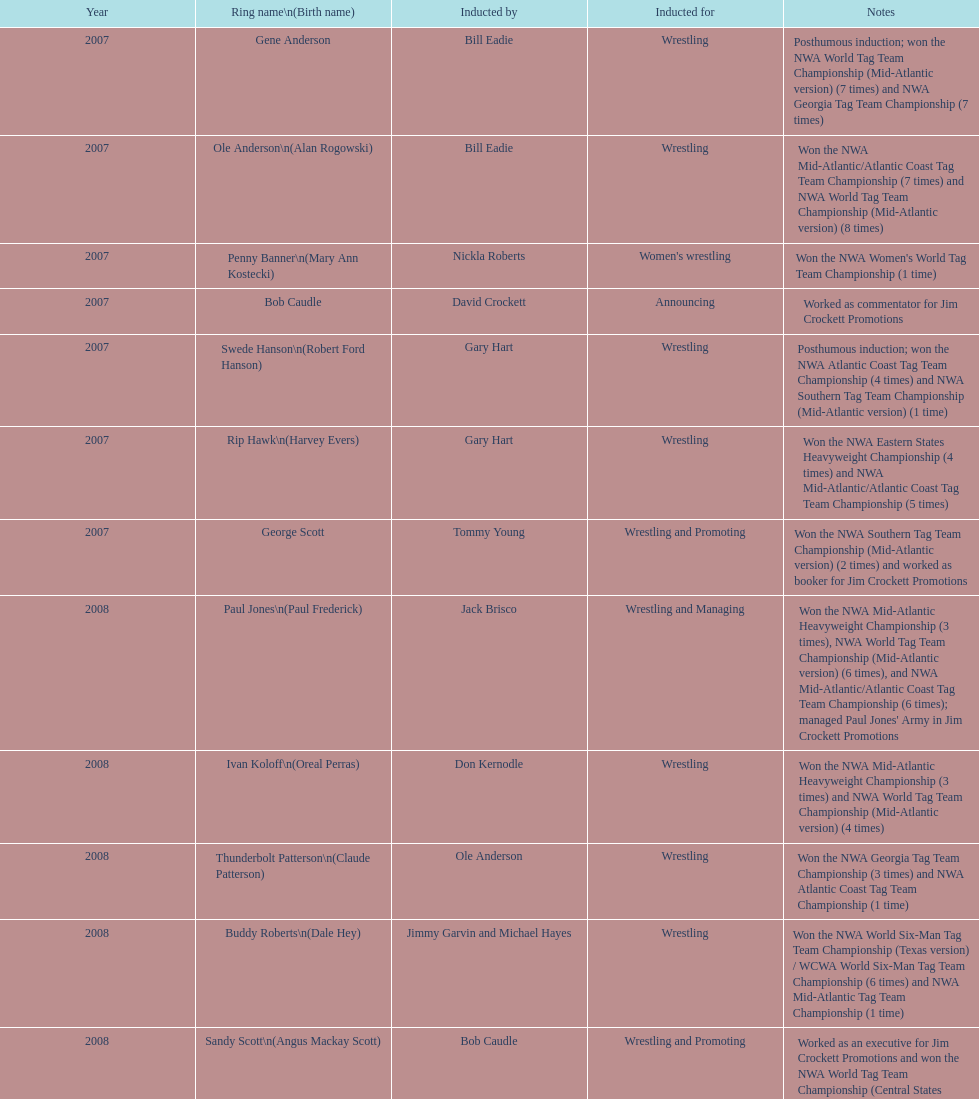Who was the only person to be inducted for wrestling and managing? Paul Jones. Can you give me this table as a dict? {'header': ['Year', 'Ring name\\n(Birth name)', 'Inducted by', 'Inducted for', 'Notes'], 'rows': [['2007', 'Gene Anderson', 'Bill Eadie', 'Wrestling', 'Posthumous induction; won the NWA World Tag Team Championship (Mid-Atlantic version) (7 times) and NWA Georgia Tag Team Championship (7 times)'], ['2007', 'Ole Anderson\\n(Alan Rogowski)', 'Bill Eadie', 'Wrestling', 'Won the NWA Mid-Atlantic/Atlantic Coast Tag Team Championship (7 times) and NWA World Tag Team Championship (Mid-Atlantic version) (8 times)'], ['2007', 'Penny Banner\\n(Mary Ann Kostecki)', 'Nickla Roberts', "Women's wrestling", "Won the NWA Women's World Tag Team Championship (1 time)"], ['2007', 'Bob Caudle', 'David Crockett', 'Announcing', 'Worked as commentator for Jim Crockett Promotions'], ['2007', 'Swede Hanson\\n(Robert Ford Hanson)', 'Gary Hart', 'Wrestling', 'Posthumous induction; won the NWA Atlantic Coast Tag Team Championship (4 times) and NWA Southern Tag Team Championship (Mid-Atlantic version) (1 time)'], ['2007', 'Rip Hawk\\n(Harvey Evers)', 'Gary Hart', 'Wrestling', 'Won the NWA Eastern States Heavyweight Championship (4 times) and NWA Mid-Atlantic/Atlantic Coast Tag Team Championship (5 times)'], ['2007', 'George Scott', 'Tommy Young', 'Wrestling and Promoting', 'Won the NWA Southern Tag Team Championship (Mid-Atlantic version) (2 times) and worked as booker for Jim Crockett Promotions'], ['2008', 'Paul Jones\\n(Paul Frederick)', 'Jack Brisco', 'Wrestling and Managing', "Won the NWA Mid-Atlantic Heavyweight Championship (3 times), NWA World Tag Team Championship (Mid-Atlantic version) (6 times), and NWA Mid-Atlantic/Atlantic Coast Tag Team Championship (6 times); managed Paul Jones' Army in Jim Crockett Promotions"], ['2008', 'Ivan Koloff\\n(Oreal Perras)', 'Don Kernodle', 'Wrestling', 'Won the NWA Mid-Atlantic Heavyweight Championship (3 times) and NWA World Tag Team Championship (Mid-Atlantic version) (4 times)'], ['2008', 'Thunderbolt Patterson\\n(Claude Patterson)', 'Ole Anderson', 'Wrestling', 'Won the NWA Georgia Tag Team Championship (3 times) and NWA Atlantic Coast Tag Team Championship (1 time)'], ['2008', 'Buddy Roberts\\n(Dale Hey)', 'Jimmy Garvin and Michael Hayes', 'Wrestling', 'Won the NWA World Six-Man Tag Team Championship (Texas version) / WCWA World Six-Man Tag Team Championship (6 times) and NWA Mid-Atlantic Tag Team Championship (1 time)'], ['2008', 'Sandy Scott\\n(Angus Mackay Scott)', 'Bob Caudle', 'Wrestling and Promoting', 'Worked as an executive for Jim Crockett Promotions and won the NWA World Tag Team Championship (Central States version) (1 time) and NWA Southern Tag Team Championship (Mid-Atlantic version) (3 times)'], ['2008', 'Grizzly Smith\\n(Aurelian Smith)', 'Magnum T.A.', 'Wrestling', 'Won the NWA United States Tag Team Championship (Tri-State version) (2 times) and NWA Texas Heavyweight Championship (1 time)'], ['2008', 'Johnny Weaver\\n(Kenneth Eugene Weaver)', 'Rip Hawk', 'Wrestling', 'Posthumous induction; won the NWA Atlantic Coast/Mid-Atlantic Tag Team Championship (8 times) and NWA Southern Tag Team Championship (Mid-Atlantic version) (6 times)'], ['2009', 'Don Fargo\\n(Don Kalt)', 'Jerry Jarrett & Steve Keirn', 'Wrestling', 'Won the NWA Southern Tag Team Championship (Mid-America version) (2 times) and NWA World Tag Team Championship (Mid-America version) (6 times)'], ['2009', 'Jackie Fargo\\n(Henry Faggart)', 'Jerry Jarrett & Steve Keirn', 'Wrestling', 'Won the NWA World Tag Team Championship (Mid-America version) (10 times) and NWA Southern Tag Team Championship (Mid-America version) (22 times)'], ['2009', 'Sonny Fargo\\n(Jack Lewis Faggart)', 'Jerry Jarrett & Steve Keirn', 'Wrestling', 'Posthumous induction; won the NWA Southern Tag Team Championship (Mid-America version) (3 times)'], ['2009', 'Gary Hart\\n(Gary Williams)', 'Sir Oliver Humperdink', 'Managing and Promoting', 'Posthumous induction; worked as a booker in World Class Championship Wrestling and managed several wrestlers in Mid-Atlantic Championship Wrestling'], ['2009', 'Wahoo McDaniel\\n(Edward McDaniel)', 'Tully Blanchard', 'Wrestling', 'Posthumous induction; won the NWA Mid-Atlantic Heavyweight Championship (6 times) and NWA World Tag Team Championship (Mid-Atlantic version) (4 times)'], ['2009', 'Blackjack Mulligan\\n(Robert Windham)', 'Ric Flair', 'Wrestling', 'Won the NWA Texas Heavyweight Championship (1 time) and NWA World Tag Team Championship (Mid-Atlantic version) (1 time)'], ['2009', 'Nelson Royal', 'Brad Anderson, Tommy Angel & David Isley', 'Wrestling', 'Won the NWA Atlantic Coast Tag Team Championship (2 times)'], ['2009', 'Lance Russell', 'Dave Brown', 'Announcing', 'Worked as commentator for wrestling events in the Memphis area']]} 